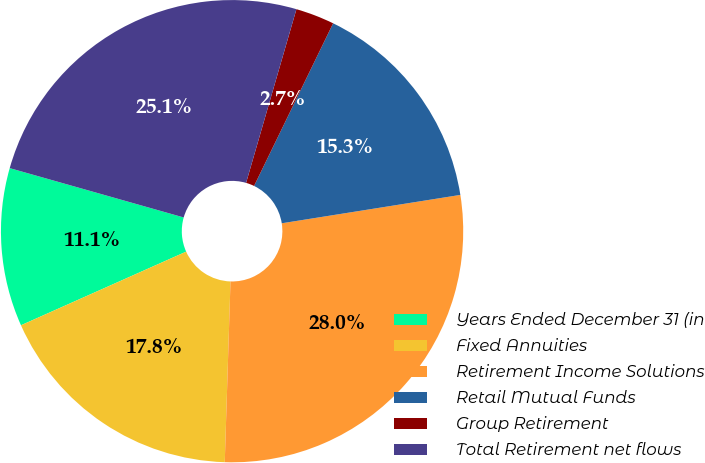Convert chart to OTSL. <chart><loc_0><loc_0><loc_500><loc_500><pie_chart><fcel>Years Ended December 31 (in<fcel>Fixed Annuities<fcel>Retirement Income Solutions<fcel>Retail Mutual Funds<fcel>Group Retirement<fcel>Total Retirement net flows<nl><fcel>11.07%<fcel>17.82%<fcel>28.01%<fcel>15.29%<fcel>2.71%<fcel>25.09%<nl></chart> 